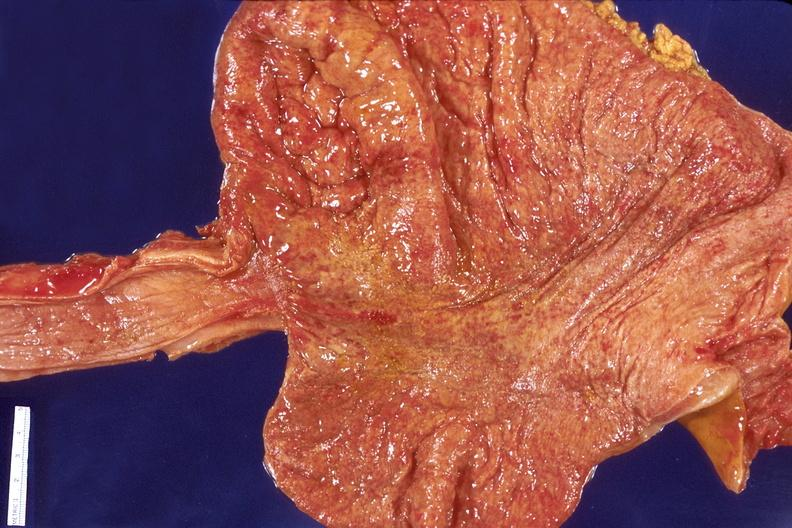s gastrointestinal present?
Answer the question using a single word or phrase. Yes 